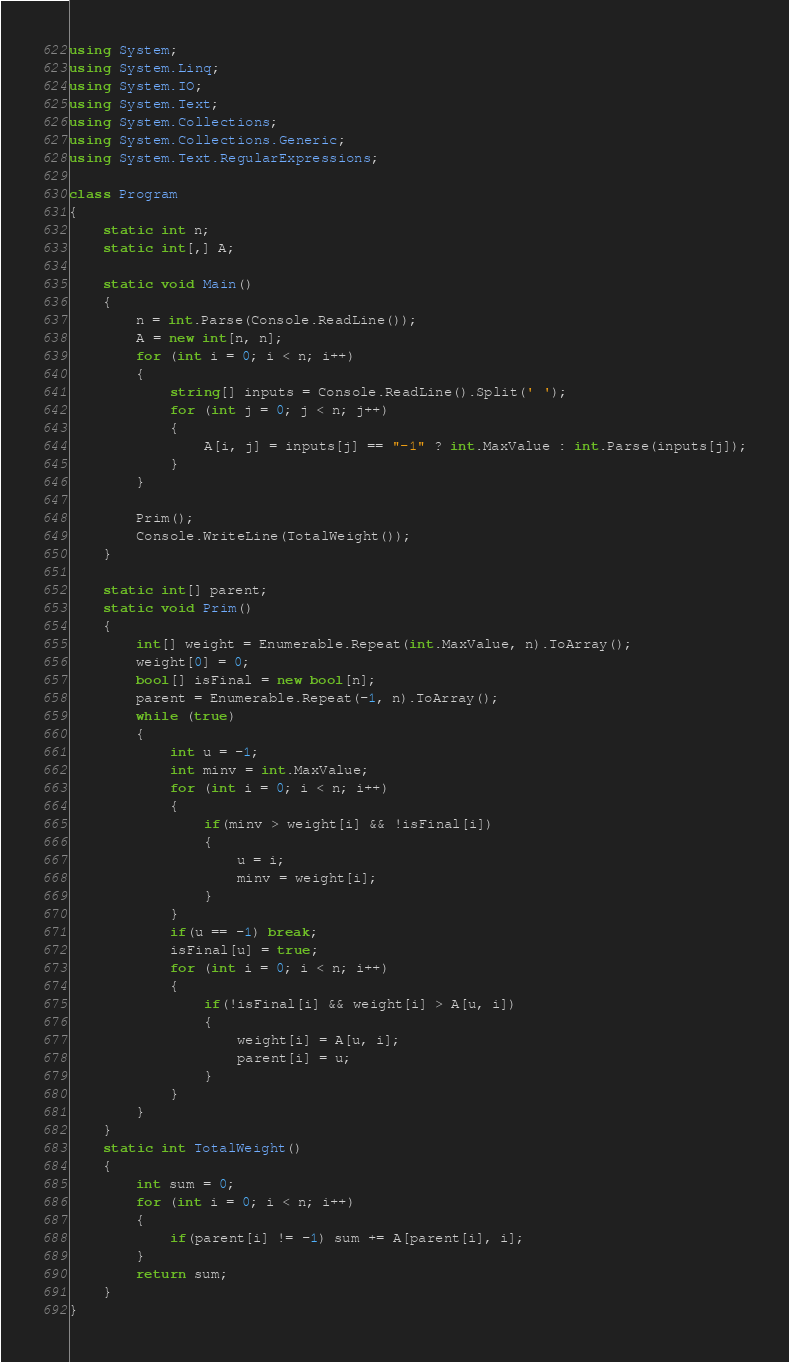<code> <loc_0><loc_0><loc_500><loc_500><_C#_>using System;
using System.Linq;
using System.IO;
using System.Text;
using System.Collections;
using System.Collections.Generic;
using System.Text.RegularExpressions;
 
class Program
{
    static int n;
    static int[,] A;

    static void Main()
    {
        n = int.Parse(Console.ReadLine());
        A = new int[n, n];
        for (int i = 0; i < n; i++)
        {
            string[] inputs = Console.ReadLine().Split(' ');
            for (int j = 0; j < n; j++)
            {
                A[i, j] = inputs[j] == "-1" ? int.MaxValue : int.Parse(inputs[j]);
            }
        }

        Prim();
        Console.WriteLine(TotalWeight());
    }

    static int[] parent;
    static void Prim()
    {
        int[] weight = Enumerable.Repeat(int.MaxValue, n).ToArray();
        weight[0] = 0;
        bool[] isFinal = new bool[n];
        parent = Enumerable.Repeat(-1, n).ToArray();
        while (true)
        {
            int u = -1;
            int minv = int.MaxValue;
            for (int i = 0; i < n; i++)
            {
                if(minv > weight[i] && !isFinal[i])
                {
                    u = i;
                    minv = weight[i];
                }
            }
            if(u == -1) break;
            isFinal[u] = true;
            for (int i = 0; i < n; i++)
            {
                if(!isFinal[i] && weight[i] > A[u, i])
                {
                    weight[i] = A[u, i];
                    parent[i] = u;
                }
            }
        }
    }
    static int TotalWeight()
    {
        int sum = 0;
        for (int i = 0; i < n; i++)
        {
            if(parent[i] != -1) sum += A[parent[i], i];
        }
        return sum;
    }
}</code> 